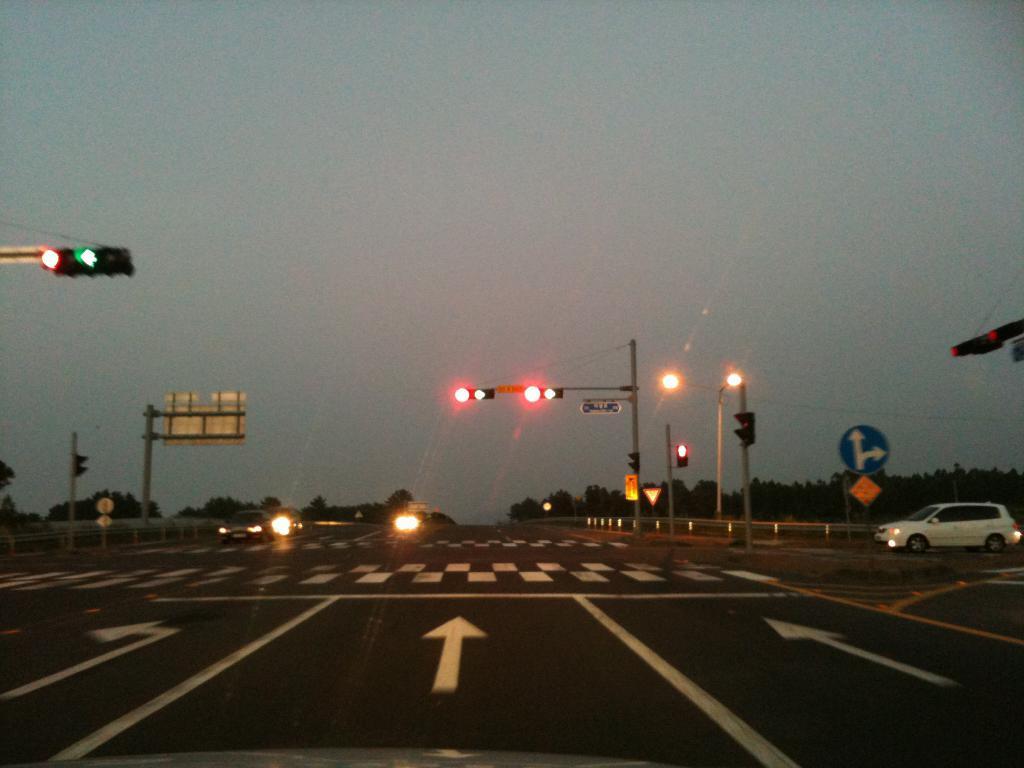Could you give a brief overview of what you see in this image? In this image there is a road at the bottom. There are metal fencing, traffic signals, in the left and right corner. There are vehicles, traffic signals in the foreground. And there is sky at the top. 